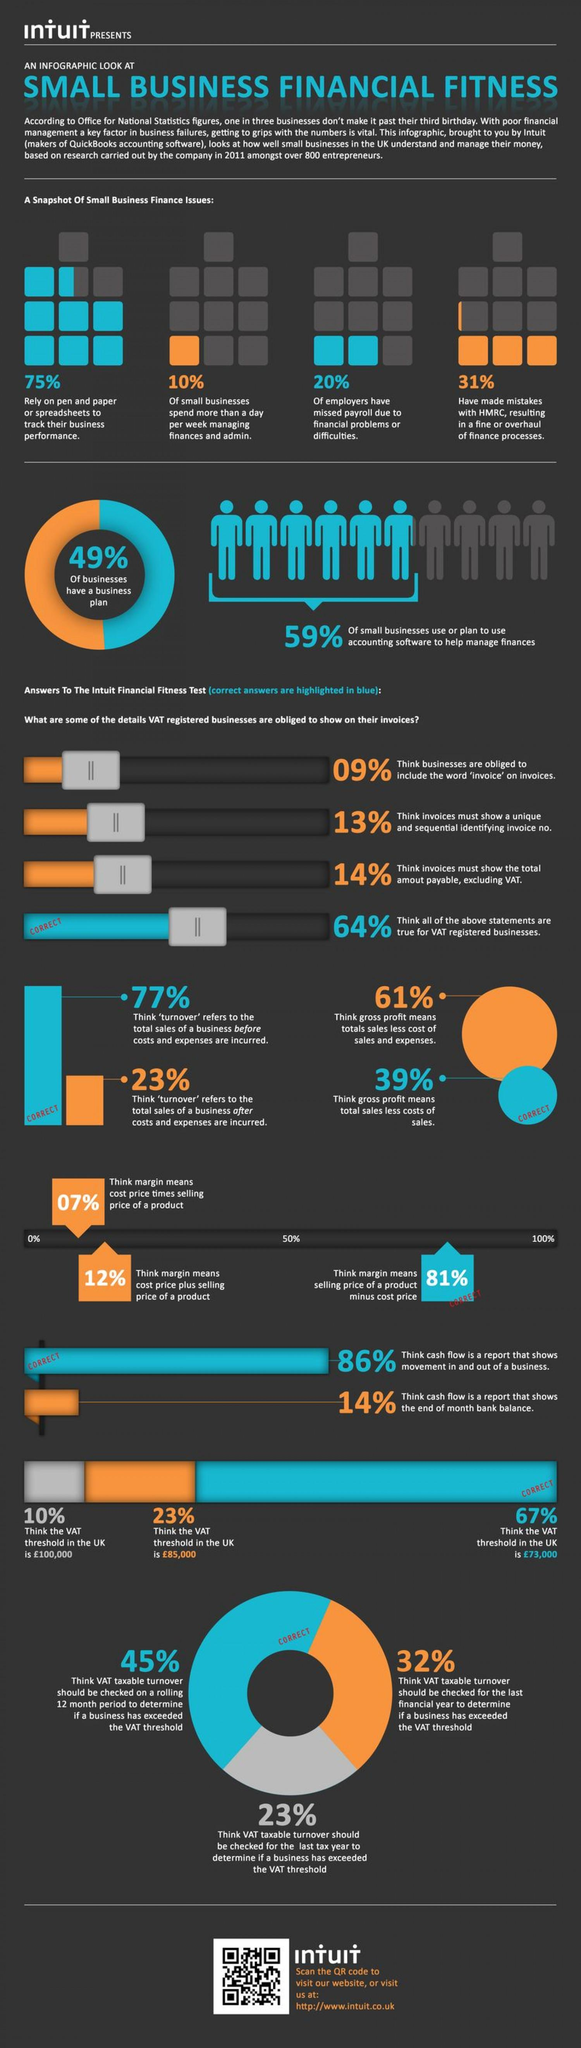Specify some key components in this picture. According to a study, only 10% of small businesses spend more than a day per week managing their finances and administrative tasks. Approximately 25% of small businesses do not rely on spreadsheets to track their business performance, according to a recent study. According to a survey conducted in the UK, 23% of businesses believe that the value of the VAT threshold is €85,000. According to a recent survey, approximately 20% of employers have missed payroll due to financial problems. According to a survey of businesses in the UK, 67% believe that the value of the VAT threshold is €73,000. 